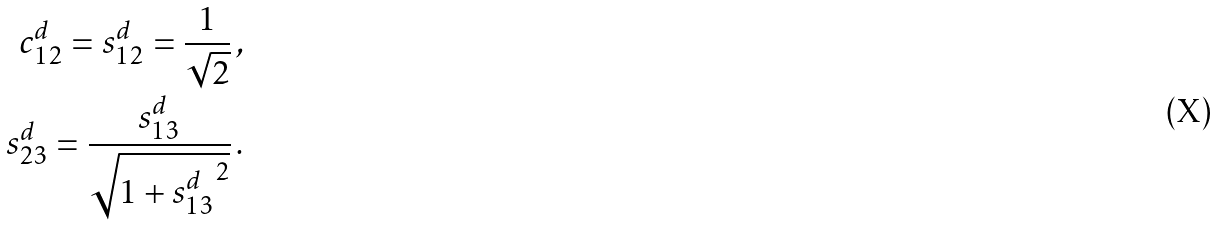<formula> <loc_0><loc_0><loc_500><loc_500>c _ { 1 2 } ^ { d } = s _ { 1 2 } ^ { d } = \frac { 1 } { \sqrt { 2 } } \, , \\ s _ { 2 3 } ^ { d } = \frac { s _ { 1 3 } ^ { d } } { \sqrt { 1 + { s _ { 1 3 } ^ { d } } ^ { 2 } } } \, .</formula> 